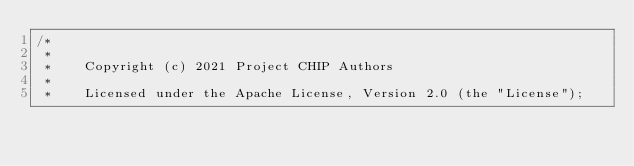<code> <loc_0><loc_0><loc_500><loc_500><_ObjectiveC_>/*
 *
 *    Copyright (c) 2021 Project CHIP Authors
 *
 *    Licensed under the Apache License, Version 2.0 (the "License");</code> 